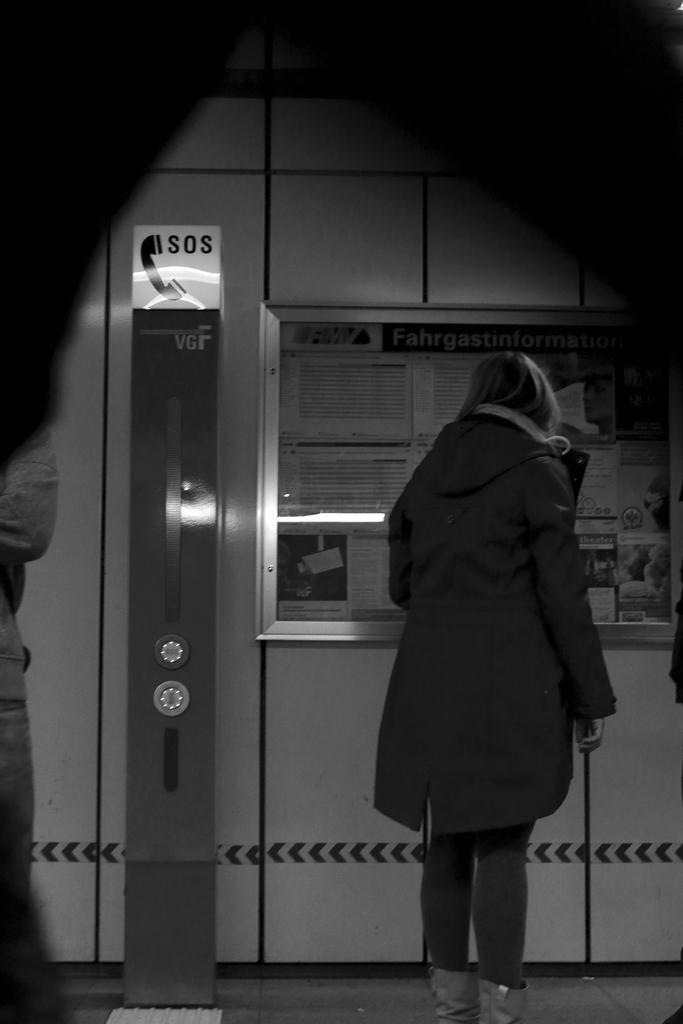Could you give a brief overview of what you see in this image? On the right there is a woman who is wearing jacket, jeans and shoe. She is standing near to the window, back side of her there is a telephone stand. On the left there is another person who is wearing t-shirt and jeans. Through the window we can see some posters. 